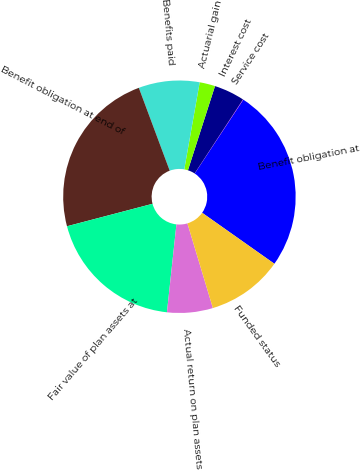<chart> <loc_0><loc_0><loc_500><loc_500><pie_chart><fcel>Benefit obligation at<fcel>Service cost<fcel>Interest cost<fcel>Actuarial gain<fcel>Benefits paid<fcel>Benefit obligation at end of<fcel>Fair value of plan assets at<fcel>Actual return on plan assets<fcel>Funded status<nl><fcel>25.52%<fcel>0.05%<fcel>4.26%<fcel>2.16%<fcel>8.47%<fcel>23.41%<fcel>19.2%<fcel>6.36%<fcel>10.57%<nl></chart> 